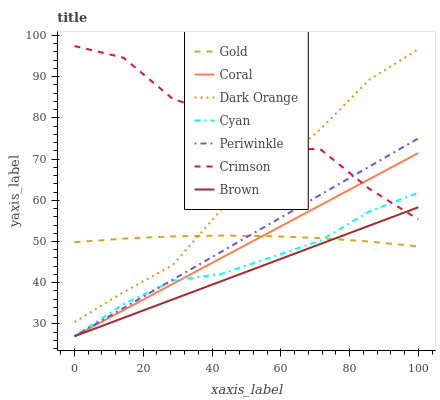Does Brown have the minimum area under the curve?
Answer yes or no. Yes. Does Crimson have the maximum area under the curve?
Answer yes or no. Yes. Does Gold have the minimum area under the curve?
Answer yes or no. No. Does Gold have the maximum area under the curve?
Answer yes or no. No. Is Brown the smoothest?
Answer yes or no. Yes. Is Crimson the roughest?
Answer yes or no. Yes. Is Gold the smoothest?
Answer yes or no. No. Is Gold the roughest?
Answer yes or no. No. Does Brown have the lowest value?
Answer yes or no. Yes. Does Gold have the lowest value?
Answer yes or no. No. Does Crimson have the highest value?
Answer yes or no. Yes. Does Brown have the highest value?
Answer yes or no. No. Is Periwinkle less than Dark Orange?
Answer yes or no. Yes. Is Dark Orange greater than Brown?
Answer yes or no. Yes. Does Cyan intersect Gold?
Answer yes or no. Yes. Is Cyan less than Gold?
Answer yes or no. No. Is Cyan greater than Gold?
Answer yes or no. No. Does Periwinkle intersect Dark Orange?
Answer yes or no. No. 